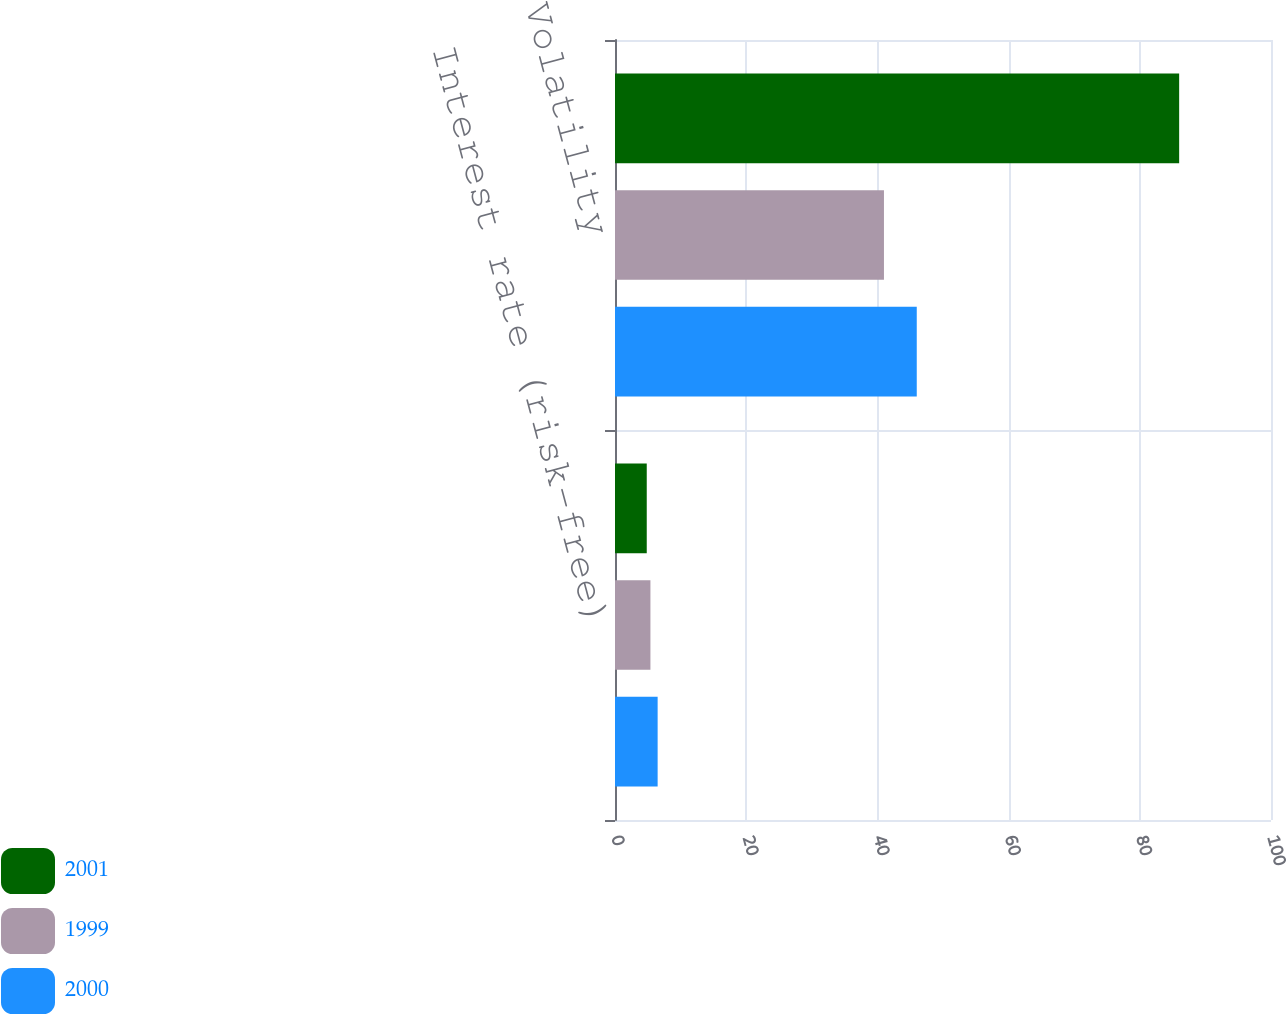<chart> <loc_0><loc_0><loc_500><loc_500><stacked_bar_chart><ecel><fcel>Interest rate (risk-free)<fcel>Volatility<nl><fcel>2001<fcel>4.84<fcel>86<nl><fcel>1999<fcel>5.4<fcel>41<nl><fcel>2000<fcel>6.5<fcel>46<nl></chart> 